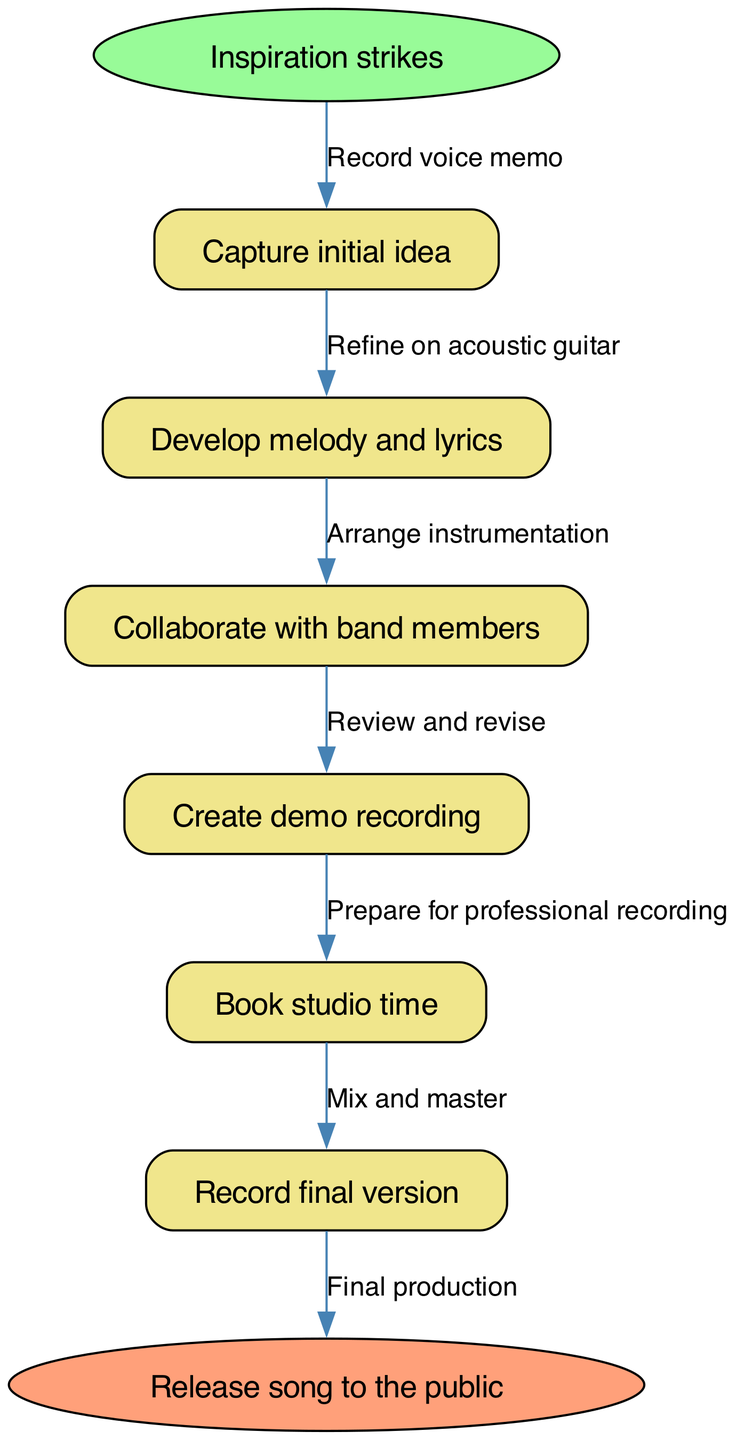What is the starting point of the songwriting process? The diagram indicates that the songwriting process begins with "Inspiration strikes." This is clearly labeled as the first node.
Answer: Inspiration strikes How many steps are involved in the process? By examining the steps listed in the diagram, there are a total of six distinct process steps before reaching the end.
Answer: 6 What follows "Capture initial idea"? The diagram shows that the step immediately following "Capture initial idea" is "Develop melody and lyrics." This indicates the direct flow between the nodes.
Answer: Develop melody and lyrics What is the last step before releasing the song? According to the diagram, the last step before the final release is "Record final version," which is indicated right before the end node.
Answer: Record final version What is the final output of the process? The final output is "Release song to the public," which is represented as the end node in the diagram.
Answer: Release song to the public What action is associated with "Create demo recording"? The edge connecting "Create demo recording" indicates the action "Review and revise," meaning that this step involves evaluating and making adjustments to the demo recording.
Answer: Review and revise Which node directly precedes the step "Record final version"? The step directly preceding "Record final version" is "Book studio time." This shows the relationship between these two process steps.
Answer: Book studio time What is the edge label between "Collaborate with band members" and "Create demo recording"? The edge label connecting these two steps is "Arrange instrumentation," which suggests that the collaboration leads to the arrangement of the music before creating a demo.
Answer: Arrange instrumentation 